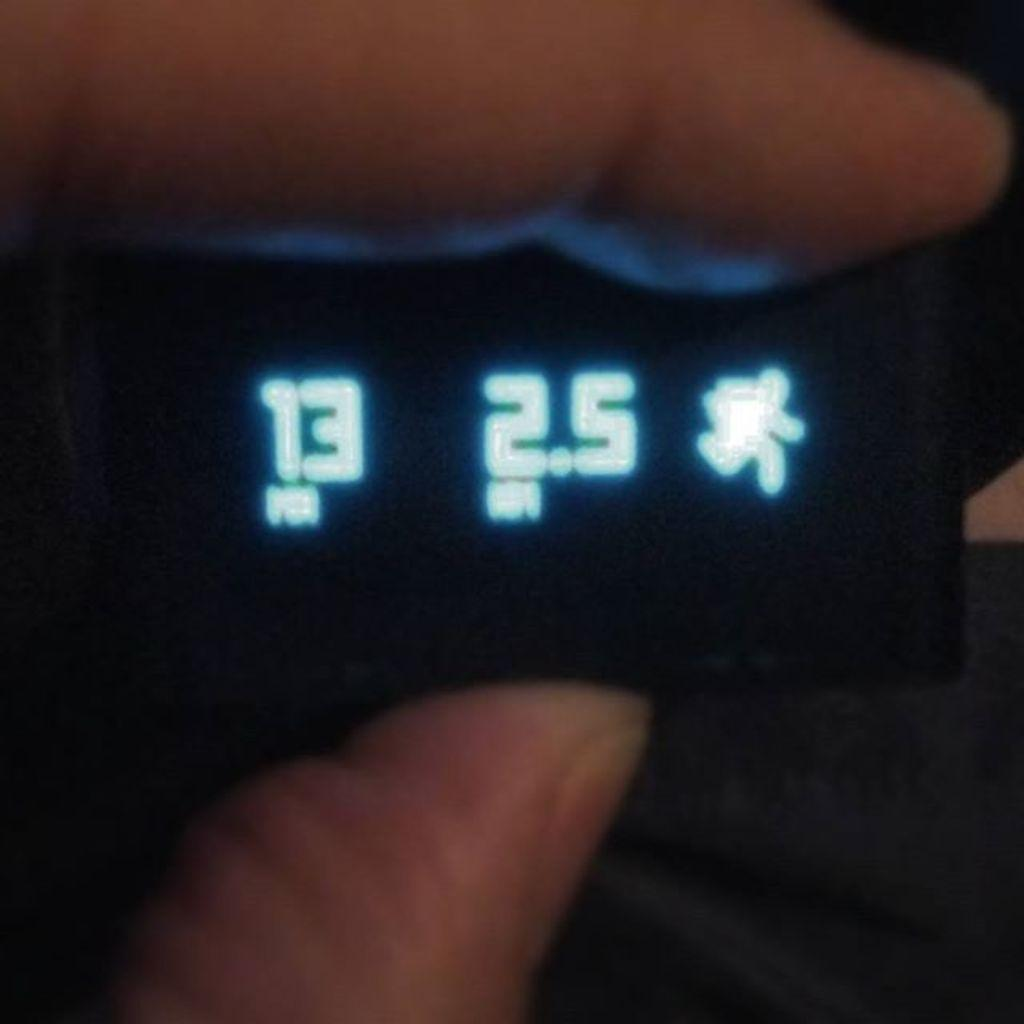What is the person holding in the image? A person's fingers are holding an object. What can be seen on the screen of the object? There are numbers visible on the screen of the object, as well as other things. Can you describe the overall lighting of the image? The image is slightly dark. What type of apparel is being worn by the steam in the image? There is no steam present in the image, and therefore no apparel can be associated with it. 